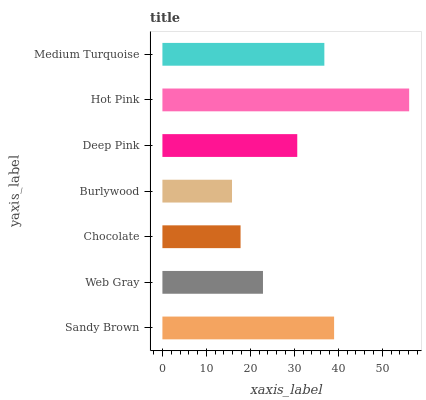Is Burlywood the minimum?
Answer yes or no. Yes. Is Hot Pink the maximum?
Answer yes or no. Yes. Is Web Gray the minimum?
Answer yes or no. No. Is Web Gray the maximum?
Answer yes or no. No. Is Sandy Brown greater than Web Gray?
Answer yes or no. Yes. Is Web Gray less than Sandy Brown?
Answer yes or no. Yes. Is Web Gray greater than Sandy Brown?
Answer yes or no. No. Is Sandy Brown less than Web Gray?
Answer yes or no. No. Is Deep Pink the high median?
Answer yes or no. Yes. Is Deep Pink the low median?
Answer yes or no. Yes. Is Hot Pink the high median?
Answer yes or no. No. Is Burlywood the low median?
Answer yes or no. No. 